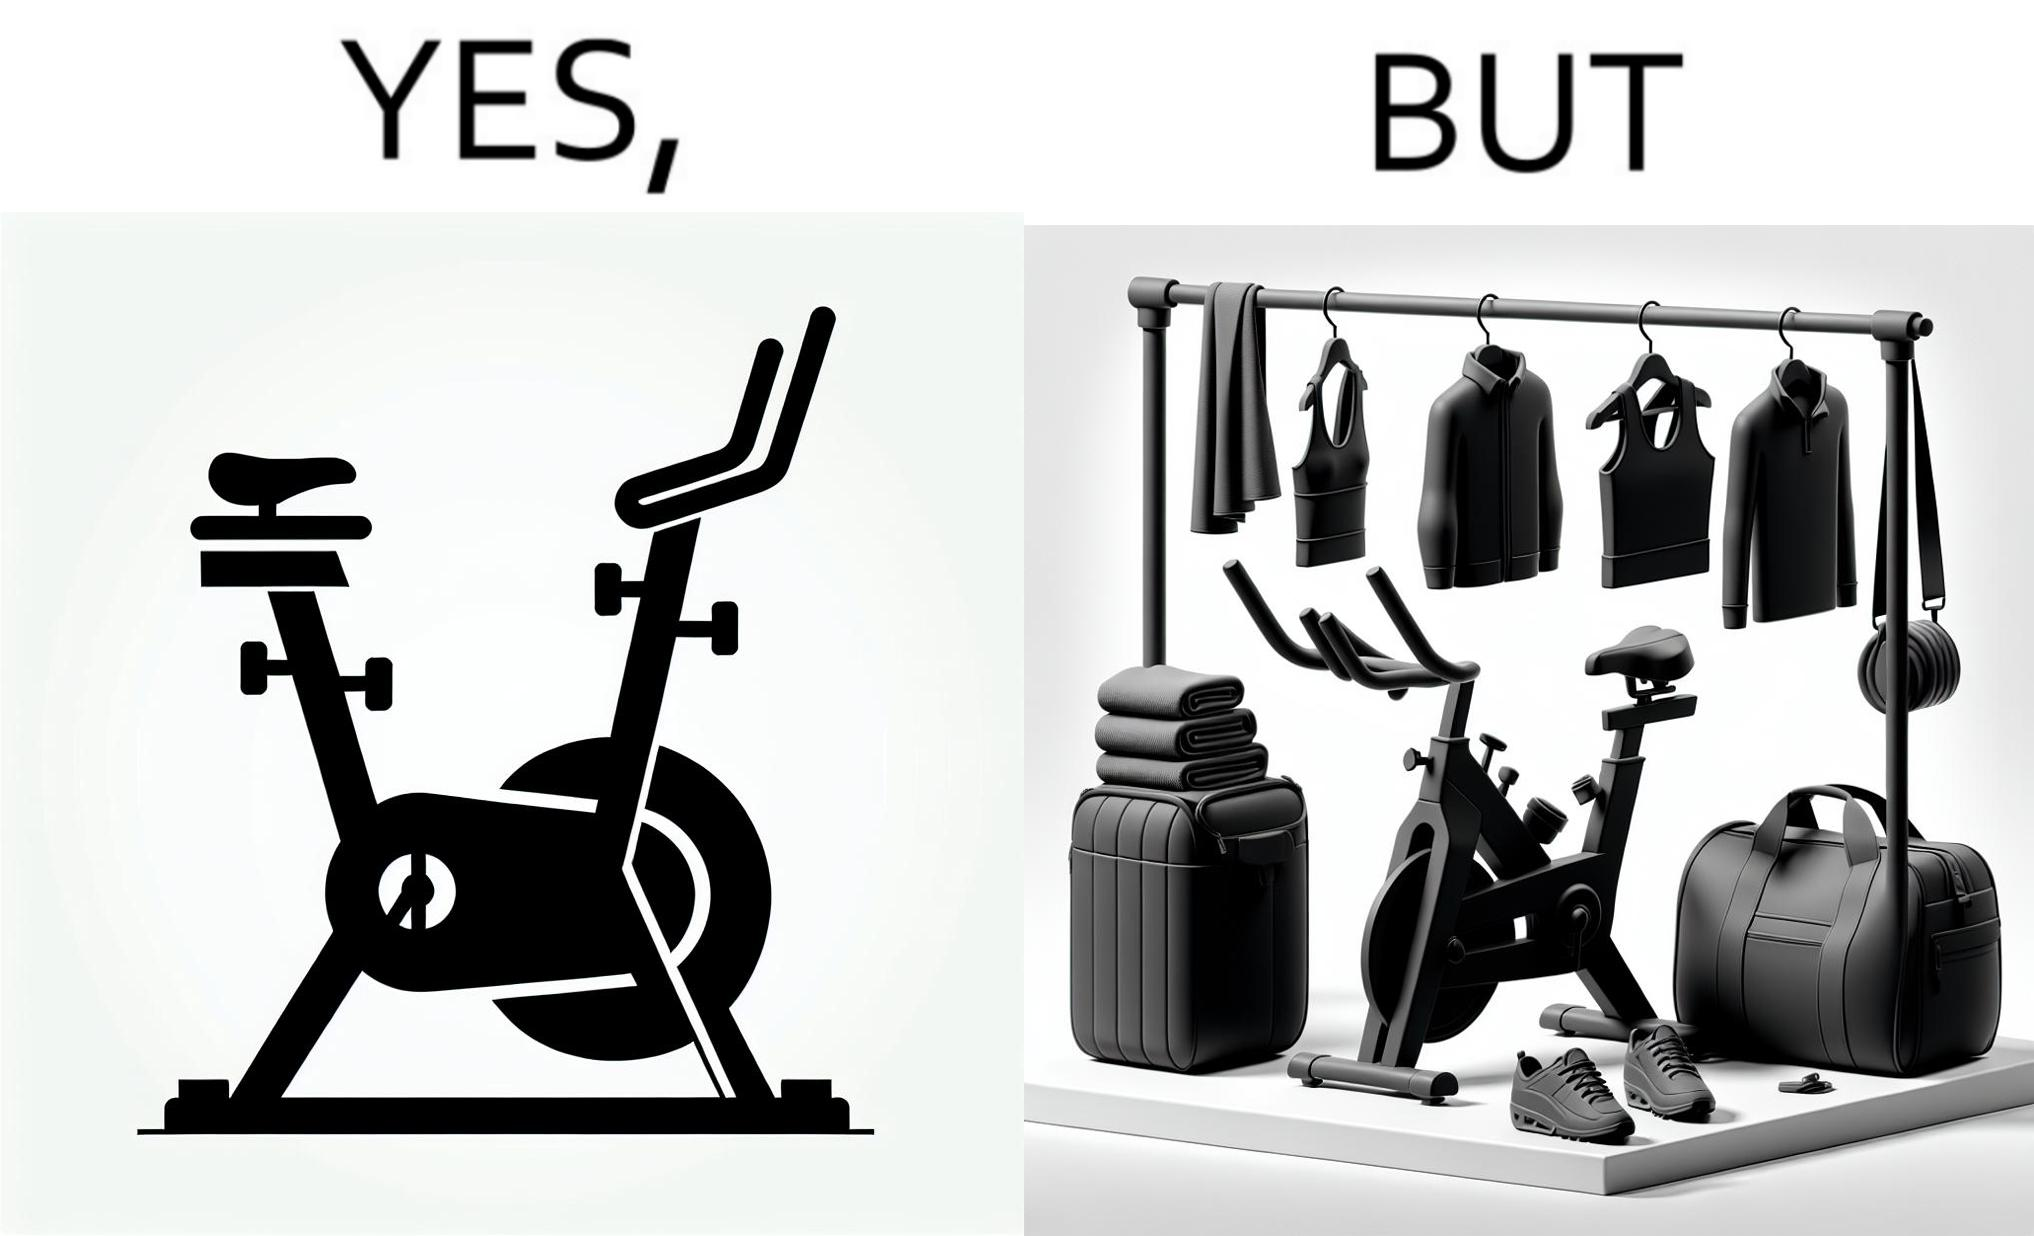Would you classify this image as satirical? Yes, this image is satirical. 